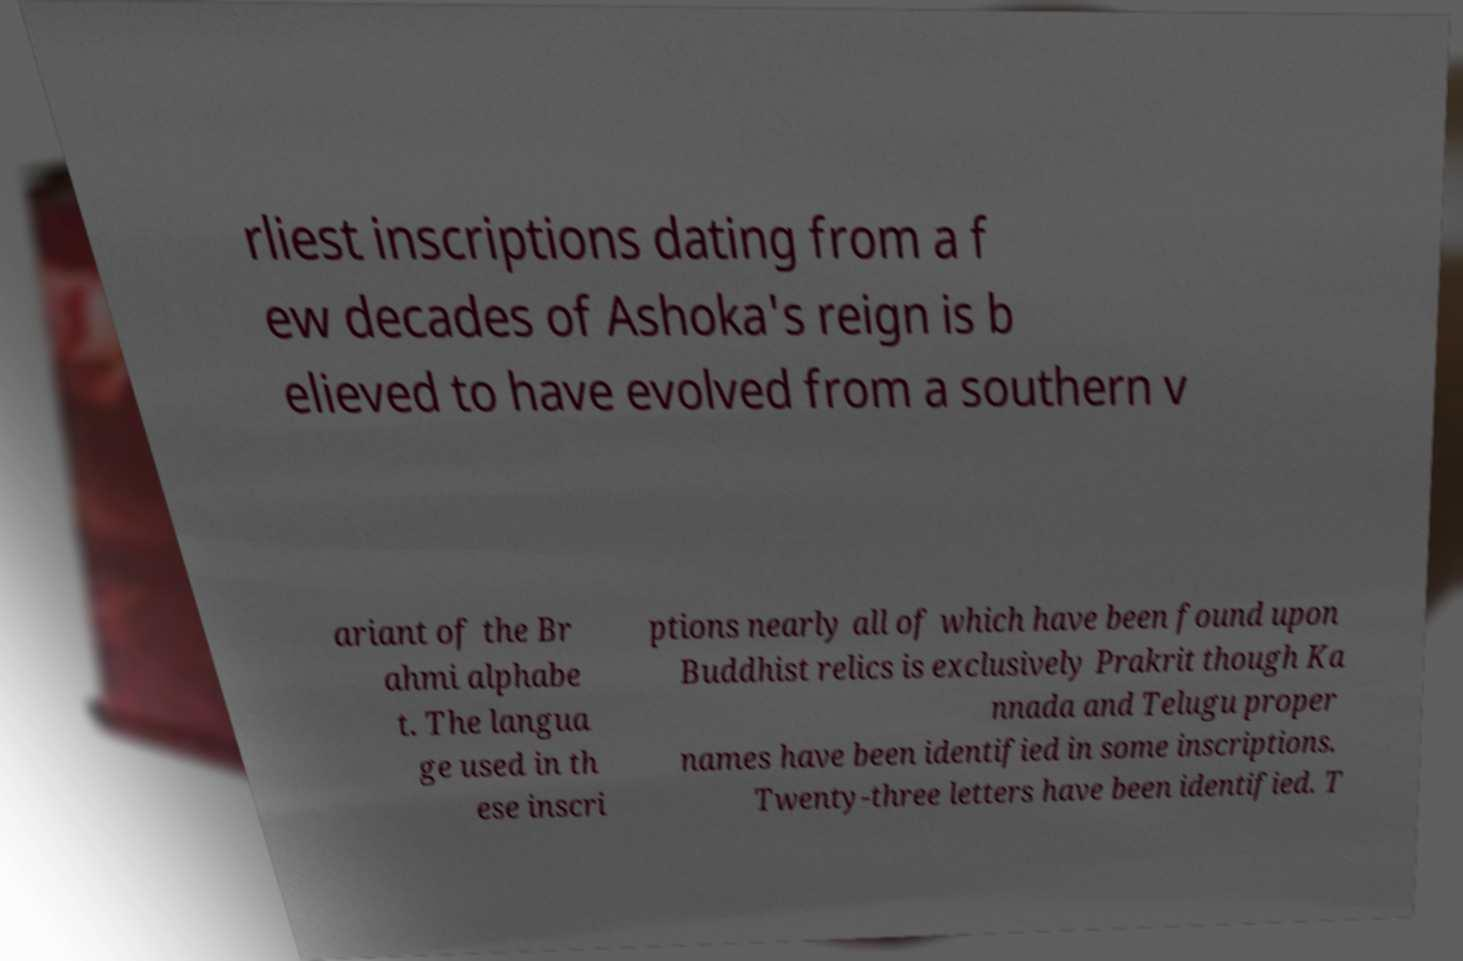I need the written content from this picture converted into text. Can you do that? rliest inscriptions dating from a f ew decades of Ashoka's reign is b elieved to have evolved from a southern v ariant of the Br ahmi alphabe t. The langua ge used in th ese inscri ptions nearly all of which have been found upon Buddhist relics is exclusively Prakrit though Ka nnada and Telugu proper names have been identified in some inscriptions. Twenty-three letters have been identified. T 